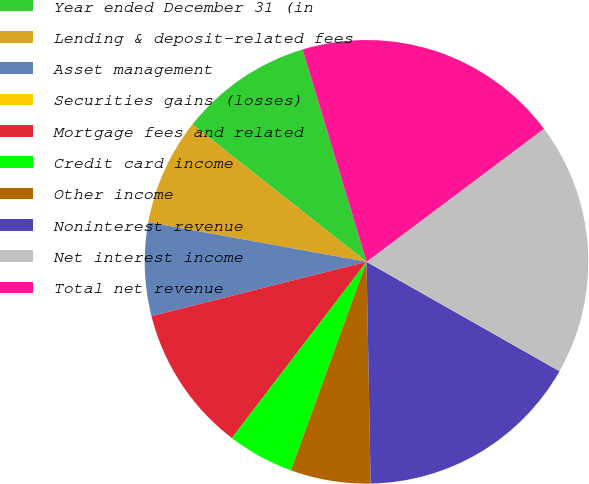<chart> <loc_0><loc_0><loc_500><loc_500><pie_chart><fcel>Year ended December 31 (in<fcel>Lending & deposit-related fees<fcel>Asset management<fcel>Securities gains (losses)<fcel>Mortgage fees and related<fcel>Credit card income<fcel>Other income<fcel>Noninterest revenue<fcel>Net interest income<fcel>Total net revenue<nl><fcel>9.71%<fcel>7.77%<fcel>6.8%<fcel>0.0%<fcel>10.68%<fcel>4.85%<fcel>5.83%<fcel>16.5%<fcel>18.45%<fcel>19.42%<nl></chart> 